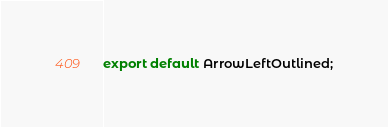<code> <loc_0><loc_0><loc_500><loc_500><_JavaScript_>export default ArrowLeftOutlined;
</code> 